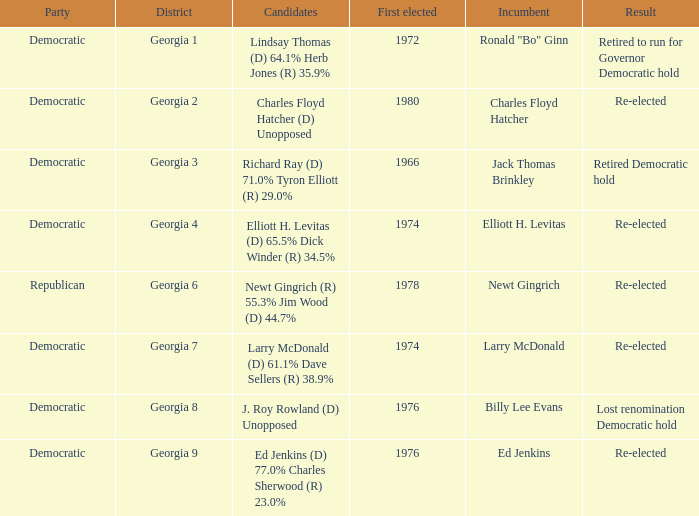Name the party for jack thomas brinkley Democratic. 